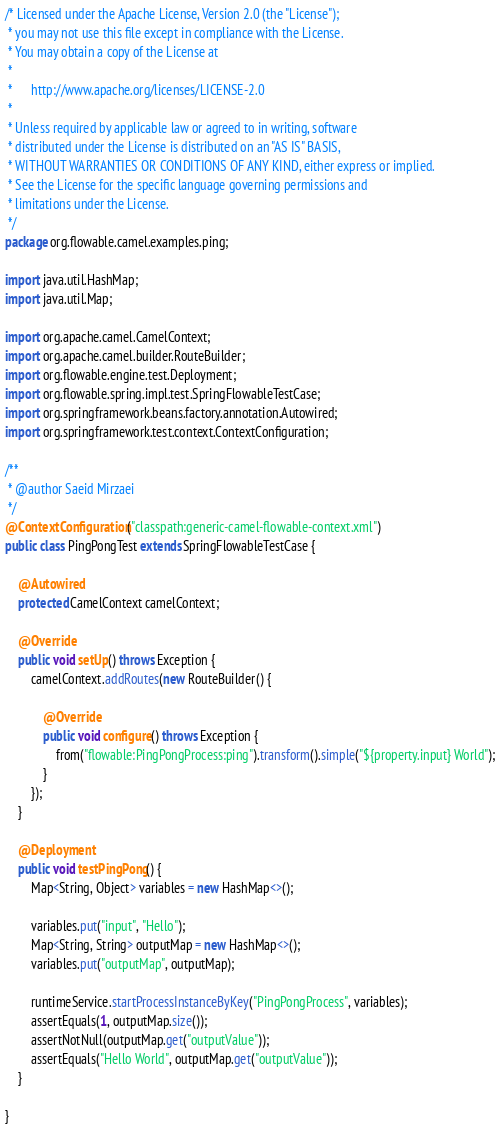Convert code to text. <code><loc_0><loc_0><loc_500><loc_500><_Java_>/* Licensed under the Apache License, Version 2.0 (the "License");
 * you may not use this file except in compliance with the License.
 * You may obtain a copy of the License at
 *
 *      http://www.apache.org/licenses/LICENSE-2.0
 *
 * Unless required by applicable law or agreed to in writing, software
 * distributed under the License is distributed on an "AS IS" BASIS,
 * WITHOUT WARRANTIES OR CONDITIONS OF ANY KIND, either express or implied.
 * See the License for the specific language governing permissions and
 * limitations under the License.
 */
package org.flowable.camel.examples.ping;

import java.util.HashMap;
import java.util.Map;

import org.apache.camel.CamelContext;
import org.apache.camel.builder.RouteBuilder;
import org.flowable.engine.test.Deployment;
import org.flowable.spring.impl.test.SpringFlowableTestCase;
import org.springframework.beans.factory.annotation.Autowired;
import org.springframework.test.context.ContextConfiguration;

/**
 * @author Saeid Mirzaei
 */
@ContextConfiguration("classpath:generic-camel-flowable-context.xml")
public class PingPongTest extends SpringFlowableTestCase {

    @Autowired
    protected CamelContext camelContext;

    @Override
    public void setUp() throws Exception {
        camelContext.addRoutes(new RouteBuilder() {

            @Override
            public void configure() throws Exception {
                from("flowable:PingPongProcess:ping").transform().simple("${property.input} World");
            }
        });
    }

    @Deployment
    public void testPingPong() {
        Map<String, Object> variables = new HashMap<>();

        variables.put("input", "Hello");
        Map<String, String> outputMap = new HashMap<>();
        variables.put("outputMap", outputMap);

        runtimeService.startProcessInstanceByKey("PingPongProcess", variables);
        assertEquals(1, outputMap.size());
        assertNotNull(outputMap.get("outputValue"));
        assertEquals("Hello World", outputMap.get("outputValue"));
    }

}
</code> 